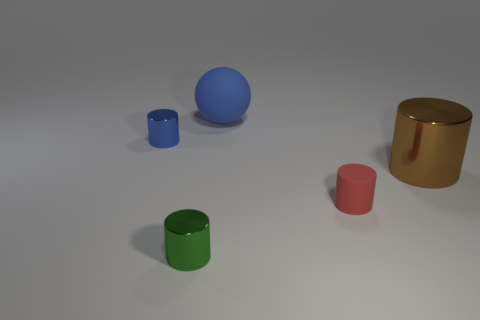Subtract all big brown shiny cylinders. How many cylinders are left? 3 Add 4 big cyan shiny blocks. How many objects exist? 9 Subtract all brown cylinders. How many cylinders are left? 3 Subtract 1 cylinders. How many cylinders are left? 3 Subtract all cylinders. How many objects are left? 1 Subtract all purple matte cylinders. Subtract all tiny shiny cylinders. How many objects are left? 3 Add 4 small shiny cylinders. How many small shiny cylinders are left? 6 Add 1 brown matte cubes. How many brown matte cubes exist? 1 Subtract 0 gray cylinders. How many objects are left? 5 Subtract all cyan cylinders. Subtract all cyan spheres. How many cylinders are left? 4 